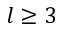<formula> <loc_0><loc_0><loc_500><loc_500>l \geq 3</formula> 